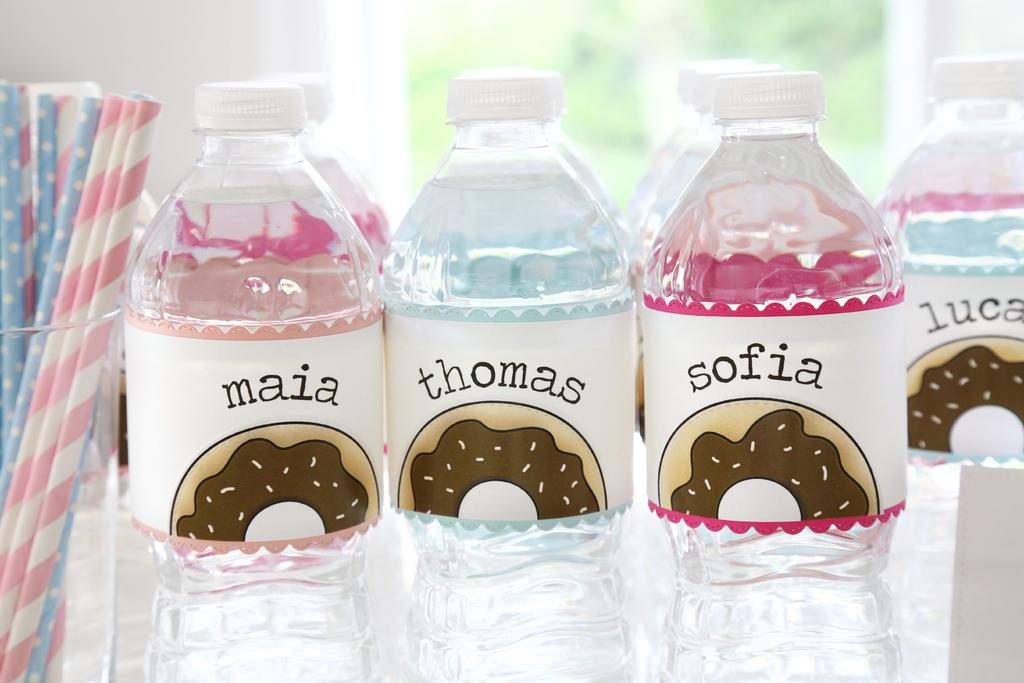<image>
Render a clear and concise summary of the photo. Bottles of water called maia, thomas and sofia with more in the background. 